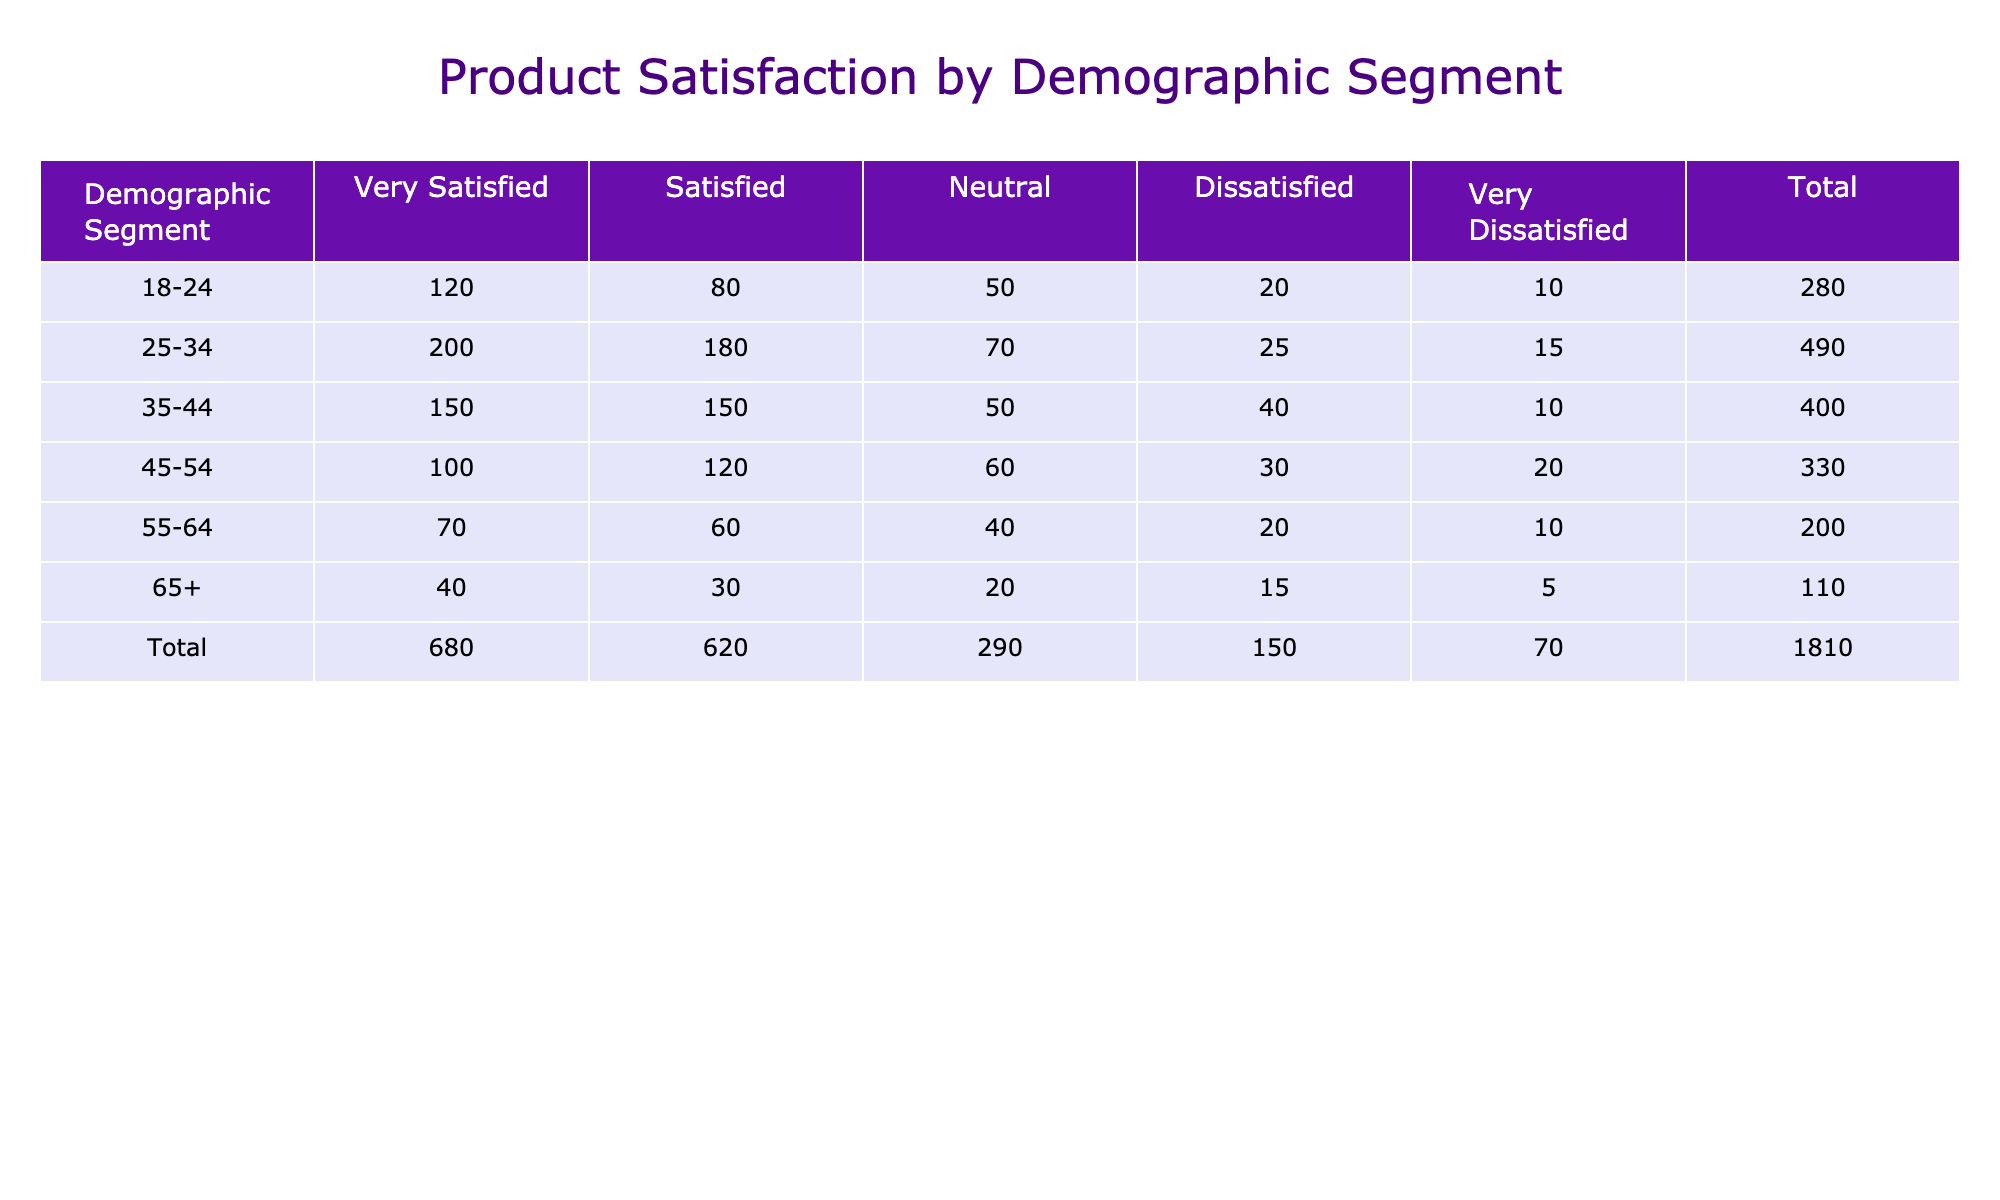What is the total number of respondents aged 25-34 who are very satisfied with the product? The table shows that for the demographic segment 25-34, the number of respondents who are very satisfied is listed under the column 'Very Satisfied' as 200. Therefore, the total number of respondents aged 25-34 who are very satisfied with the product is 200.
Answer: 200 Which demographic segment has the highest number of "Dissatisfied" responses? To find this, we look at the 'Dissatisfied' row for each demographic segment. The values are: 20 (18-24), 25 (25-34), 40 (35-44), 30 (45-54), 20 (55-64), and 15 (65+). The highest value here is 40 for the demographic segment 35-44. Therefore, the segment with the highest number of "Dissatisfied" responses is 35-44.
Answer: 35-44 What is the total number of responses for ages 55-64? To get the total number of responses for the age group 55-64, we need to sum all the values for that demographic segment: Very Satisfied (70) + Satisfied (60) + Neutral (40) + Dissatisfied (20) + Very Dissatisfied (10) = 200. Hence, the total number of responses for ages 55-64 is 200.
Answer: 200 Is it true that the demographic segment 18-24 has a higher total satisfaction count (very satisfied + satisfied) than the segment 65+? For the segment 18-24, the satisfaction counts are: Very Satisfied (120) + Satisfied (80) = 200. For the segment 65+, the counts are: Very Satisfied (40) + Satisfied (30) = 70. Since 200 is greater than 70, the statement is true.
Answer: Yes What is the overall 'Neutral' satisfaction rating among all demographic segments combined? We must look at the 'Neutral' column values across all segments and sum them: 50 (18-24) + 70 (25-34) + 50 (35-44) + 60 (45-54) + 40 (55-64) + 20 (65+) = 320. Therefore, the overall 'Neutral' satisfaction rating is 320.
Answer: 320 Which demographic segment has the most balanced responses across the satisfaction ratings (i.e., lesser discrepancy between the highest and lowest ratings)? For this, we calculate the discrepancy between highest and lowest responses for each demographic segment. Segment 18-24 has a range of 110 (Very Satisfied 120 - Very Dissatisfied 10), 25-34 has 185, 35-44 has 140, 45-54 has 80, 55-64 has 60, and 65+ has 35. The segment 65+ has the least discrepancy with a range of 35; thus, it is the most balanced.
Answer: 65+ What is the average number of 'Very Satisfied' ratings across all segments? We will calculate the average of the 'Very Satisfied' ratings across all demographic segments: (120 + 200 + 150 + 100 + 70 + 40) = 680. There are 6 segments, therefore the average is 680/6 = approximately 113.33. Thus, the average number of 'Very Satisfied' ratings is about 113.
Answer: 113.33 